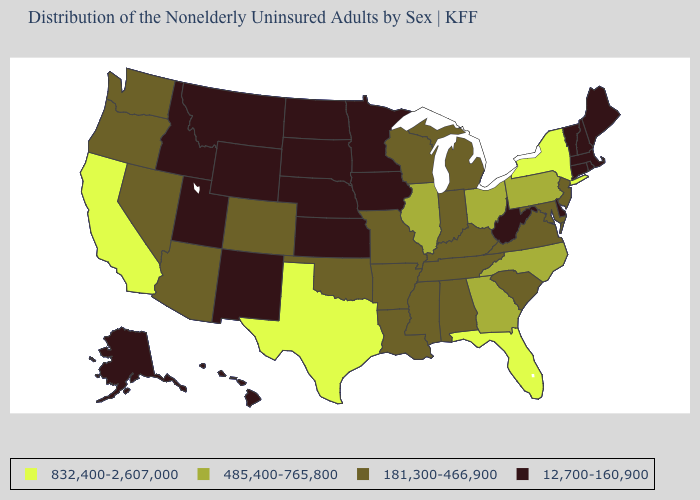Name the states that have a value in the range 832,400-2,607,000?
Write a very short answer. California, Florida, New York, Texas. What is the value of Massachusetts?
Concise answer only. 12,700-160,900. What is the value of North Dakota?
Quick response, please. 12,700-160,900. What is the lowest value in the USA?
Write a very short answer. 12,700-160,900. Does South Dakota have the lowest value in the USA?
Answer briefly. Yes. Name the states that have a value in the range 181,300-466,900?
Answer briefly. Alabama, Arizona, Arkansas, Colorado, Indiana, Kentucky, Louisiana, Maryland, Michigan, Mississippi, Missouri, Nevada, New Jersey, Oklahoma, Oregon, South Carolina, Tennessee, Virginia, Washington, Wisconsin. What is the lowest value in states that border Minnesota?
Short answer required. 12,700-160,900. Name the states that have a value in the range 832,400-2,607,000?
Write a very short answer. California, Florida, New York, Texas. What is the value of Delaware?
Be succinct. 12,700-160,900. Among the states that border New Jersey , does Delaware have the lowest value?
Write a very short answer. Yes. Does West Virginia have a lower value than Kentucky?
Short answer required. Yes. Among the states that border Wisconsin , which have the lowest value?
Quick response, please. Iowa, Minnesota. Among the states that border Vermont , does New York have the lowest value?
Write a very short answer. No. Which states hav the highest value in the MidWest?
Write a very short answer. Illinois, Ohio. What is the value of Texas?
Keep it brief. 832,400-2,607,000. 